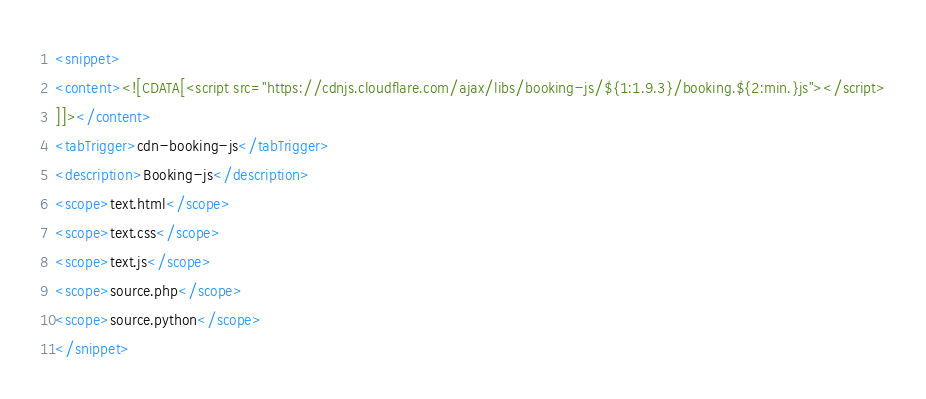Convert code to text. <code><loc_0><loc_0><loc_500><loc_500><_XML_><snippet>
<content><![CDATA[<script src="https://cdnjs.cloudflare.com/ajax/libs/booking-js/${1:1.9.3}/booking.${2:min.}js"></script>
]]></content>
<tabTrigger>cdn-booking-js</tabTrigger>
<description>Booking-js</description>
<scope>text.html</scope>
<scope>text.css</scope>
<scope>text.js</scope>
<scope>source.php</scope>
<scope>source.python</scope>
</snippet></code> 